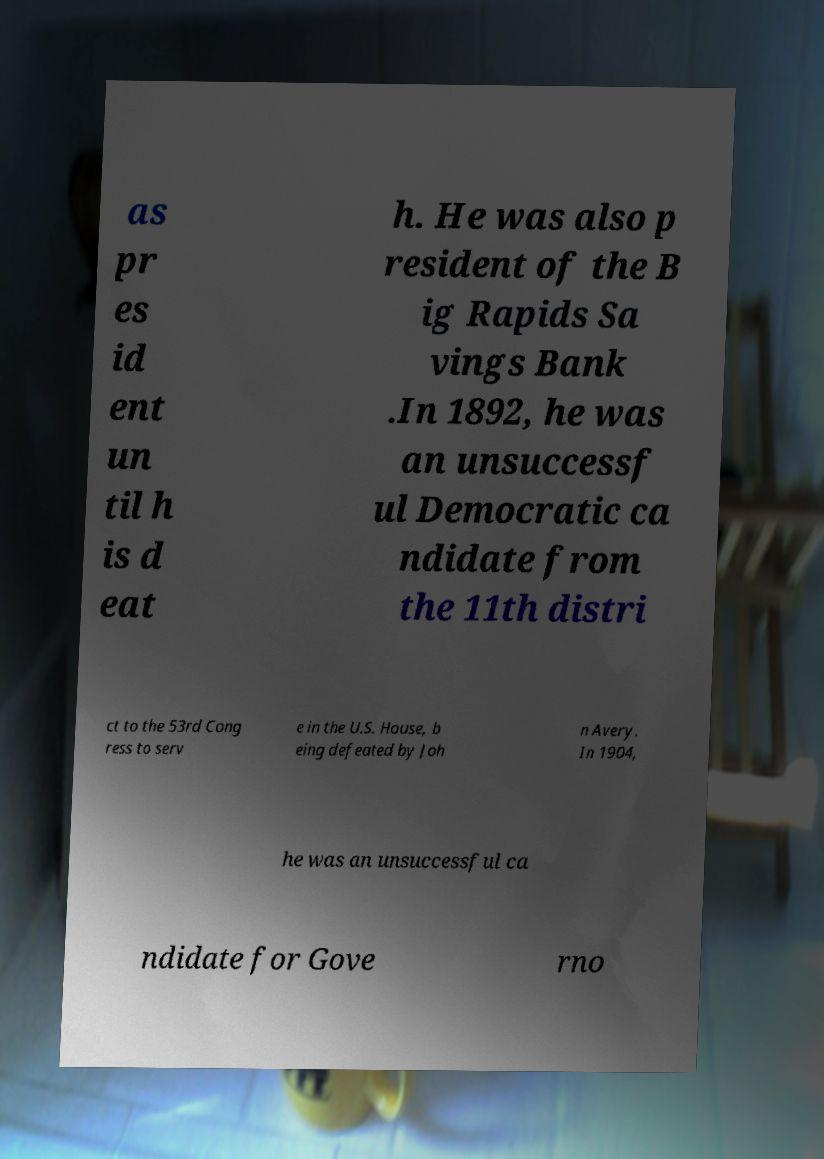Please identify and transcribe the text found in this image. as pr es id ent un til h is d eat h. He was also p resident of the B ig Rapids Sa vings Bank .In 1892, he was an unsuccessf ul Democratic ca ndidate from the 11th distri ct to the 53rd Cong ress to serv e in the U.S. House, b eing defeated by Joh n Avery. In 1904, he was an unsuccessful ca ndidate for Gove rno 